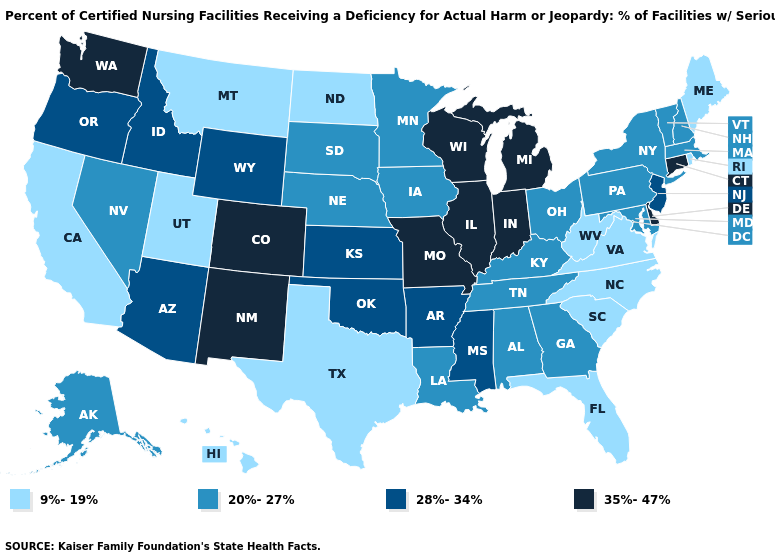Does the map have missing data?
Give a very brief answer. No. Does North Carolina have the lowest value in the South?
Write a very short answer. Yes. Does Connecticut have the highest value in the USA?
Keep it brief. Yes. Among the states that border Missouri , which have the lowest value?
Be succinct. Iowa, Kentucky, Nebraska, Tennessee. Which states have the lowest value in the West?
Be succinct. California, Hawaii, Montana, Utah. What is the value of New Mexico?
Quick response, please. 35%-47%. What is the highest value in the USA?
Give a very brief answer. 35%-47%. Which states hav the highest value in the West?
Quick response, please. Colorado, New Mexico, Washington. What is the value of Iowa?
Concise answer only. 20%-27%. Among the states that border Texas , does New Mexico have the highest value?
Keep it brief. Yes. What is the highest value in the USA?
Give a very brief answer. 35%-47%. How many symbols are there in the legend?
Short answer required. 4. What is the value of North Carolina?
Answer briefly. 9%-19%. Name the states that have a value in the range 35%-47%?
Write a very short answer. Colorado, Connecticut, Delaware, Illinois, Indiana, Michigan, Missouri, New Mexico, Washington, Wisconsin. Name the states that have a value in the range 35%-47%?
Give a very brief answer. Colorado, Connecticut, Delaware, Illinois, Indiana, Michigan, Missouri, New Mexico, Washington, Wisconsin. 